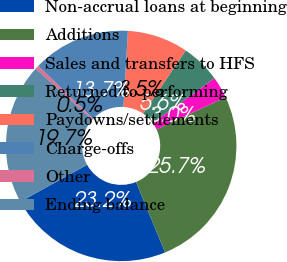Convert chart. <chart><loc_0><loc_0><loc_500><loc_500><pie_chart><fcel>Non-accrual loans at beginning<fcel>Additions<fcel>Sales and transfers to HFS<fcel>Returned to performing<fcel>Paydowns/settlements<fcel>Charge-offs<fcel>Other<fcel>Ending balance<nl><fcel>23.18%<fcel>25.74%<fcel>3.03%<fcel>5.55%<fcel>8.53%<fcel>13.72%<fcel>0.51%<fcel>19.74%<nl></chart> 